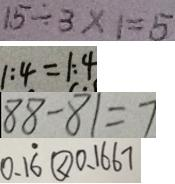Convert formula to latex. <formula><loc_0><loc_0><loc_500><loc_500>1 5 \div 3 \times 1 = 5 
 1 : 4 = 1 : 4 
 8 8 - 8 1 = 7 
 0 . 1 \dot { 6 } \textcircled { < } 0 . 1 6 6 7</formula> 